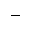<formula> <loc_0><loc_0><loc_500><loc_500>-</formula> 